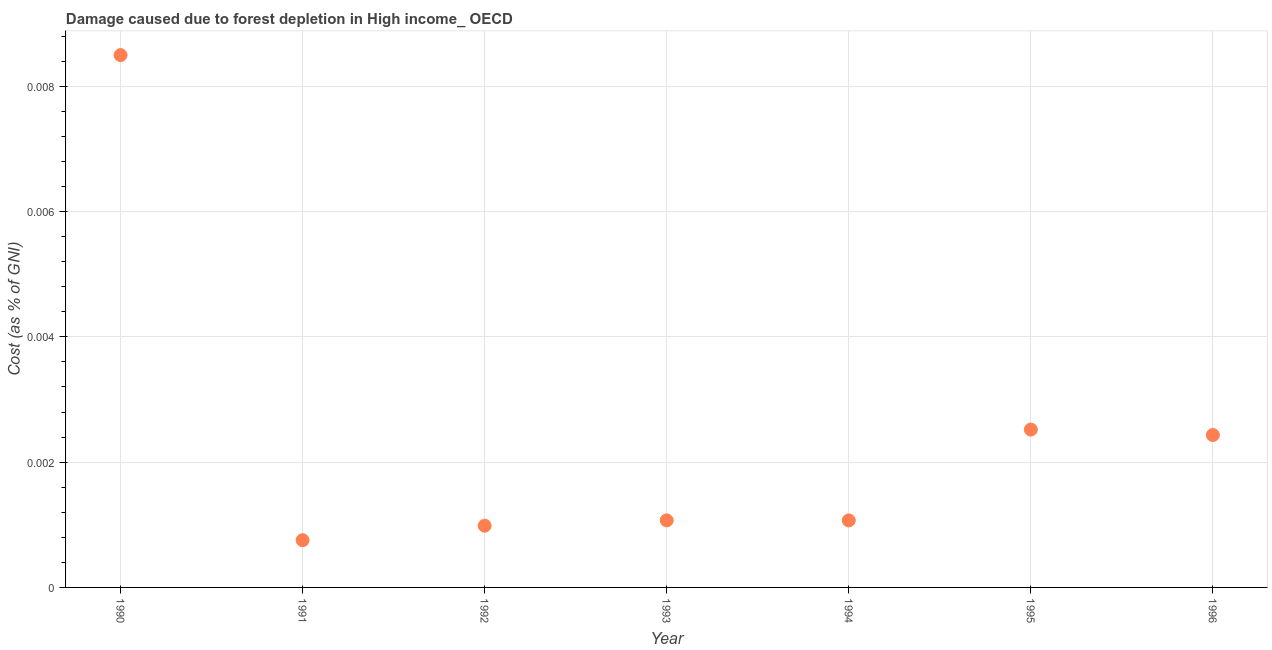What is the damage caused due to forest depletion in 1990?
Keep it short and to the point. 0.01. Across all years, what is the maximum damage caused due to forest depletion?
Ensure brevity in your answer.  0.01. Across all years, what is the minimum damage caused due to forest depletion?
Your answer should be very brief. 0. In which year was the damage caused due to forest depletion minimum?
Provide a short and direct response. 1991. What is the sum of the damage caused due to forest depletion?
Provide a succinct answer. 0.02. What is the difference between the damage caused due to forest depletion in 1992 and 1996?
Provide a succinct answer. -0. What is the average damage caused due to forest depletion per year?
Ensure brevity in your answer.  0. What is the median damage caused due to forest depletion?
Your response must be concise. 0. In how many years, is the damage caused due to forest depletion greater than 0.0076 %?
Provide a succinct answer. 1. Do a majority of the years between 1996 and 1994 (inclusive) have damage caused due to forest depletion greater than 0.0052 %?
Provide a succinct answer. No. What is the ratio of the damage caused due to forest depletion in 1993 to that in 1996?
Your answer should be compact. 0.44. Is the damage caused due to forest depletion in 1990 less than that in 1994?
Give a very brief answer. No. What is the difference between the highest and the second highest damage caused due to forest depletion?
Give a very brief answer. 0.01. Is the sum of the damage caused due to forest depletion in 1992 and 1995 greater than the maximum damage caused due to forest depletion across all years?
Give a very brief answer. No. What is the difference between the highest and the lowest damage caused due to forest depletion?
Offer a terse response. 0.01. In how many years, is the damage caused due to forest depletion greater than the average damage caused due to forest depletion taken over all years?
Give a very brief answer. 2. Does the damage caused due to forest depletion monotonically increase over the years?
Offer a very short reply. No. How many dotlines are there?
Provide a succinct answer. 1. How many years are there in the graph?
Keep it short and to the point. 7. What is the difference between two consecutive major ticks on the Y-axis?
Ensure brevity in your answer.  0. Are the values on the major ticks of Y-axis written in scientific E-notation?
Ensure brevity in your answer.  No. Does the graph contain grids?
Provide a short and direct response. Yes. What is the title of the graph?
Make the answer very short. Damage caused due to forest depletion in High income_ OECD. What is the label or title of the Y-axis?
Give a very brief answer. Cost (as % of GNI). What is the Cost (as % of GNI) in 1990?
Your answer should be compact. 0.01. What is the Cost (as % of GNI) in 1991?
Provide a succinct answer. 0. What is the Cost (as % of GNI) in 1992?
Provide a succinct answer. 0. What is the Cost (as % of GNI) in 1993?
Ensure brevity in your answer.  0. What is the Cost (as % of GNI) in 1994?
Offer a terse response. 0. What is the Cost (as % of GNI) in 1995?
Provide a short and direct response. 0. What is the Cost (as % of GNI) in 1996?
Give a very brief answer. 0. What is the difference between the Cost (as % of GNI) in 1990 and 1991?
Your response must be concise. 0.01. What is the difference between the Cost (as % of GNI) in 1990 and 1992?
Offer a very short reply. 0.01. What is the difference between the Cost (as % of GNI) in 1990 and 1993?
Offer a very short reply. 0.01. What is the difference between the Cost (as % of GNI) in 1990 and 1994?
Your answer should be very brief. 0.01. What is the difference between the Cost (as % of GNI) in 1990 and 1995?
Your response must be concise. 0.01. What is the difference between the Cost (as % of GNI) in 1990 and 1996?
Your response must be concise. 0.01. What is the difference between the Cost (as % of GNI) in 1991 and 1992?
Offer a terse response. -0. What is the difference between the Cost (as % of GNI) in 1991 and 1993?
Keep it short and to the point. -0. What is the difference between the Cost (as % of GNI) in 1991 and 1994?
Your response must be concise. -0. What is the difference between the Cost (as % of GNI) in 1991 and 1995?
Your answer should be very brief. -0. What is the difference between the Cost (as % of GNI) in 1991 and 1996?
Your answer should be very brief. -0. What is the difference between the Cost (as % of GNI) in 1992 and 1993?
Your answer should be very brief. -9e-5. What is the difference between the Cost (as % of GNI) in 1992 and 1994?
Provide a short and direct response. -9e-5. What is the difference between the Cost (as % of GNI) in 1992 and 1995?
Offer a very short reply. -0. What is the difference between the Cost (as % of GNI) in 1992 and 1996?
Your answer should be compact. -0. What is the difference between the Cost (as % of GNI) in 1993 and 1995?
Your response must be concise. -0. What is the difference between the Cost (as % of GNI) in 1993 and 1996?
Your answer should be very brief. -0. What is the difference between the Cost (as % of GNI) in 1994 and 1995?
Provide a succinct answer. -0. What is the difference between the Cost (as % of GNI) in 1994 and 1996?
Offer a terse response. -0. What is the difference between the Cost (as % of GNI) in 1995 and 1996?
Your response must be concise. 9e-5. What is the ratio of the Cost (as % of GNI) in 1990 to that in 1991?
Make the answer very short. 11.27. What is the ratio of the Cost (as % of GNI) in 1990 to that in 1992?
Provide a succinct answer. 8.63. What is the ratio of the Cost (as % of GNI) in 1990 to that in 1993?
Provide a succinct answer. 7.94. What is the ratio of the Cost (as % of GNI) in 1990 to that in 1994?
Ensure brevity in your answer.  7.94. What is the ratio of the Cost (as % of GNI) in 1990 to that in 1995?
Give a very brief answer. 3.37. What is the ratio of the Cost (as % of GNI) in 1990 to that in 1996?
Make the answer very short. 3.49. What is the ratio of the Cost (as % of GNI) in 1991 to that in 1992?
Offer a terse response. 0.77. What is the ratio of the Cost (as % of GNI) in 1991 to that in 1993?
Offer a very short reply. 0.7. What is the ratio of the Cost (as % of GNI) in 1991 to that in 1994?
Your response must be concise. 0.7. What is the ratio of the Cost (as % of GNI) in 1991 to that in 1995?
Your response must be concise. 0.3. What is the ratio of the Cost (as % of GNI) in 1991 to that in 1996?
Provide a short and direct response. 0.31. What is the ratio of the Cost (as % of GNI) in 1992 to that in 1994?
Offer a very short reply. 0.92. What is the ratio of the Cost (as % of GNI) in 1992 to that in 1995?
Make the answer very short. 0.39. What is the ratio of the Cost (as % of GNI) in 1992 to that in 1996?
Provide a short and direct response. 0.41. What is the ratio of the Cost (as % of GNI) in 1993 to that in 1995?
Your answer should be very brief. 0.42. What is the ratio of the Cost (as % of GNI) in 1993 to that in 1996?
Keep it short and to the point. 0.44. What is the ratio of the Cost (as % of GNI) in 1994 to that in 1995?
Ensure brevity in your answer.  0.42. What is the ratio of the Cost (as % of GNI) in 1994 to that in 1996?
Give a very brief answer. 0.44. What is the ratio of the Cost (as % of GNI) in 1995 to that in 1996?
Provide a short and direct response. 1.04. 